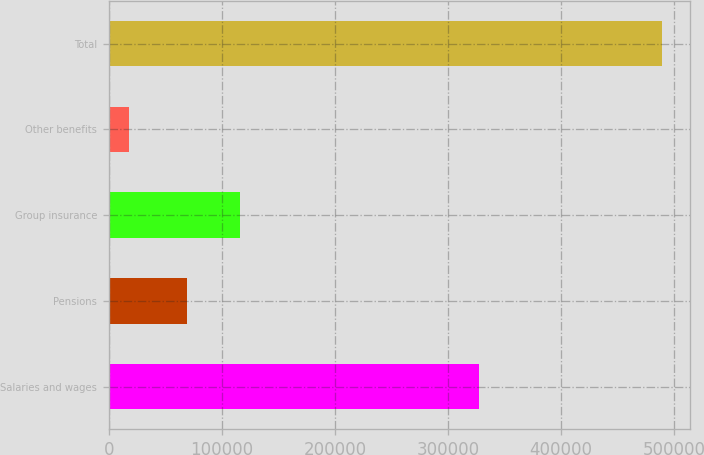Convert chart to OTSL. <chart><loc_0><loc_0><loc_500><loc_500><bar_chart><fcel>Salaries and wages<fcel>Pensions<fcel>Group insurance<fcel>Other benefits<fcel>Total<nl><fcel>327777<fcel>68885<fcel>116063<fcel>18054<fcel>489836<nl></chart> 